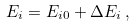Convert formula to latex. <formula><loc_0><loc_0><loc_500><loc_500>E _ { i } & = E _ { i 0 } + \Delta E _ { i } \, ,</formula> 